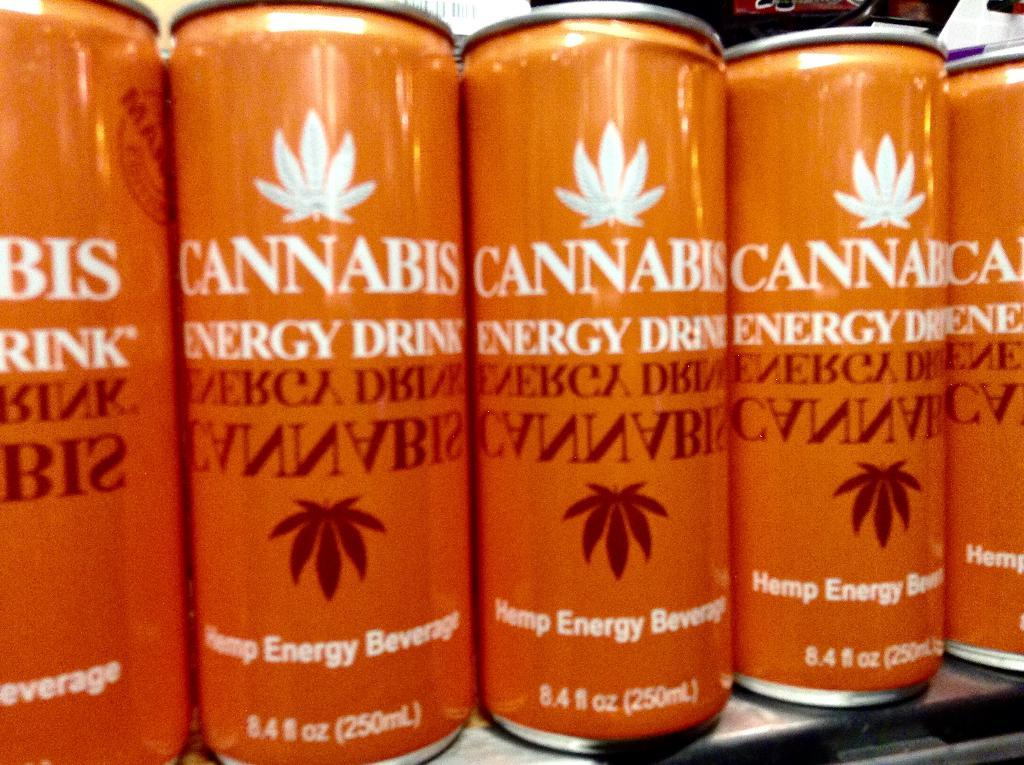<image>
Write a terse but informative summary of the picture. Cannabis energy drinks are lined up next to each other. 